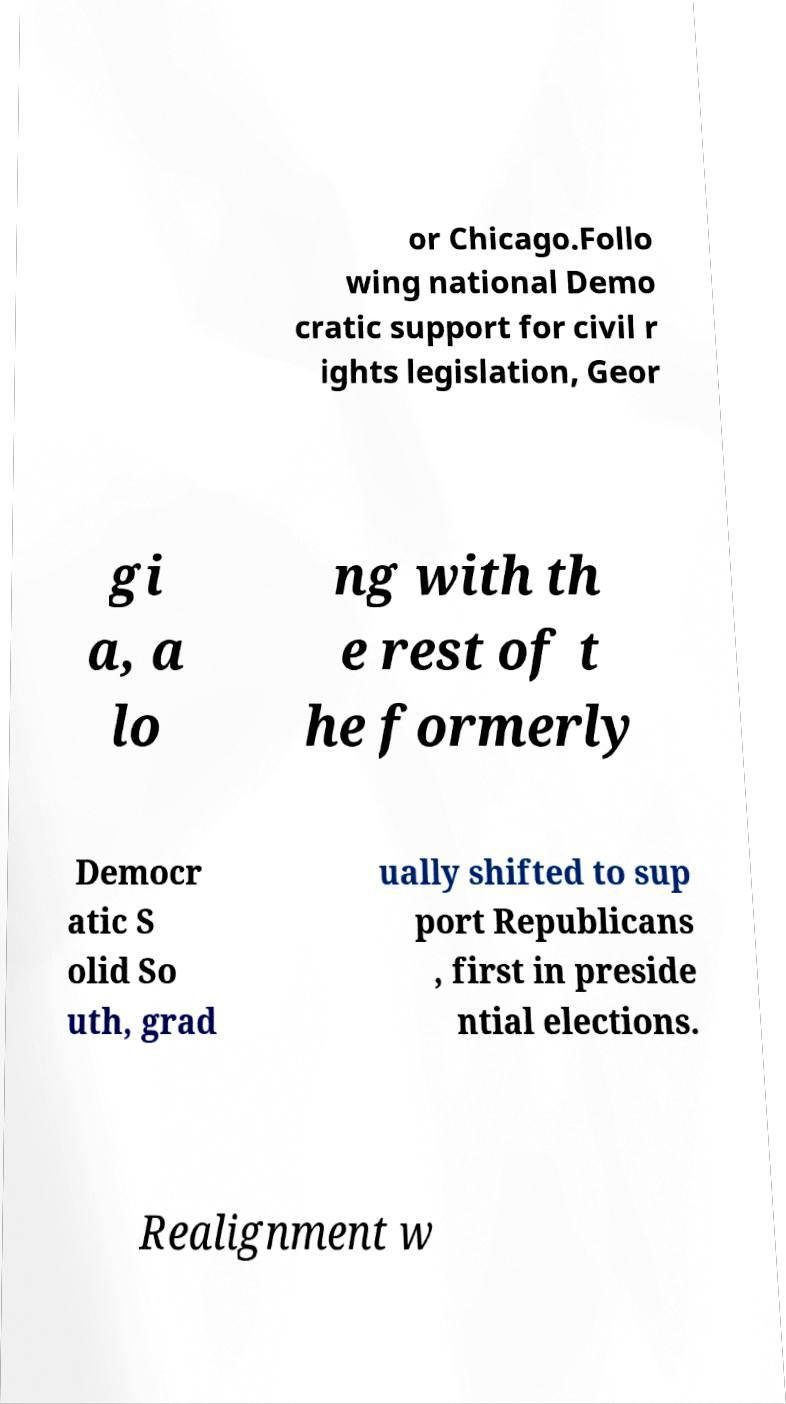Please identify and transcribe the text found in this image. or Chicago.Follo wing national Demo cratic support for civil r ights legislation, Geor gi a, a lo ng with th e rest of t he formerly Democr atic S olid So uth, grad ually shifted to sup port Republicans , first in preside ntial elections. Realignment w 